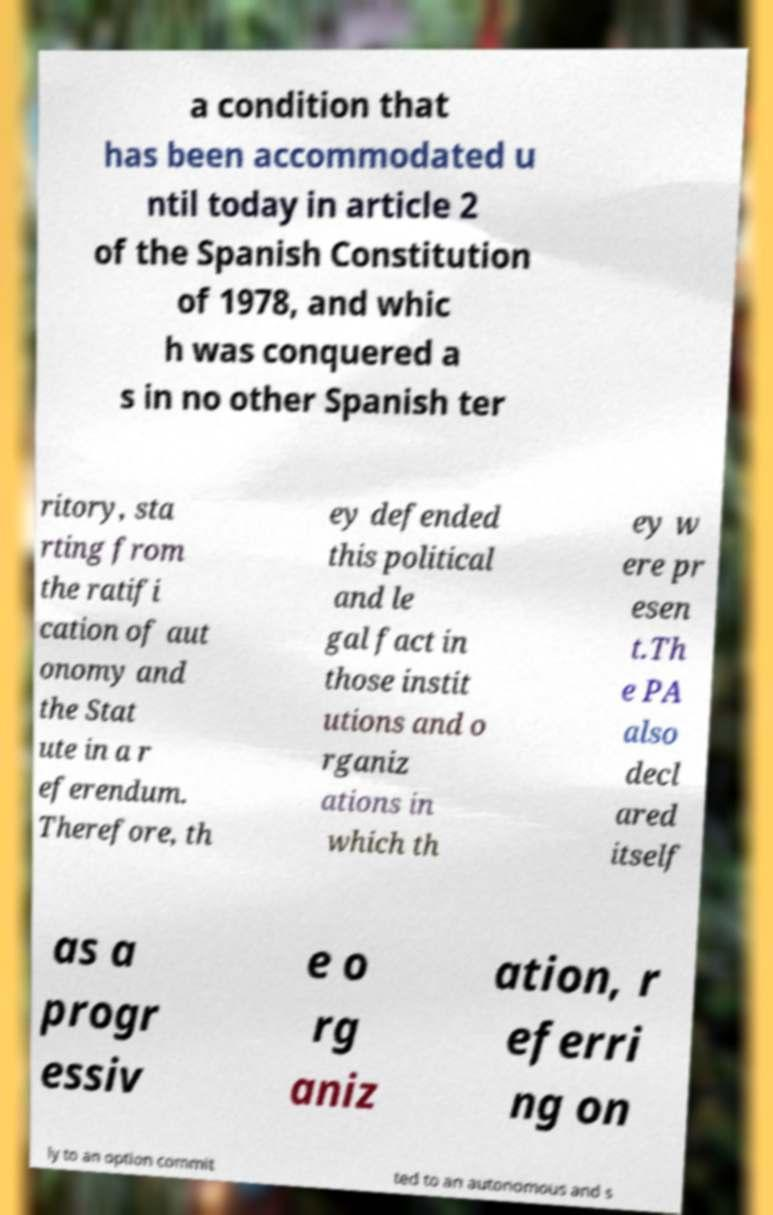For documentation purposes, I need the text within this image transcribed. Could you provide that? a condition that has been accommodated u ntil today in article 2 of the Spanish Constitution of 1978, and whic h was conquered a s in no other Spanish ter ritory, sta rting from the ratifi cation of aut onomy and the Stat ute in a r eferendum. Therefore, th ey defended this political and le gal fact in those instit utions and o rganiz ations in which th ey w ere pr esen t.Th e PA also decl ared itself as a progr essiv e o rg aniz ation, r eferri ng on ly to an option commit ted to an autonomous and s 